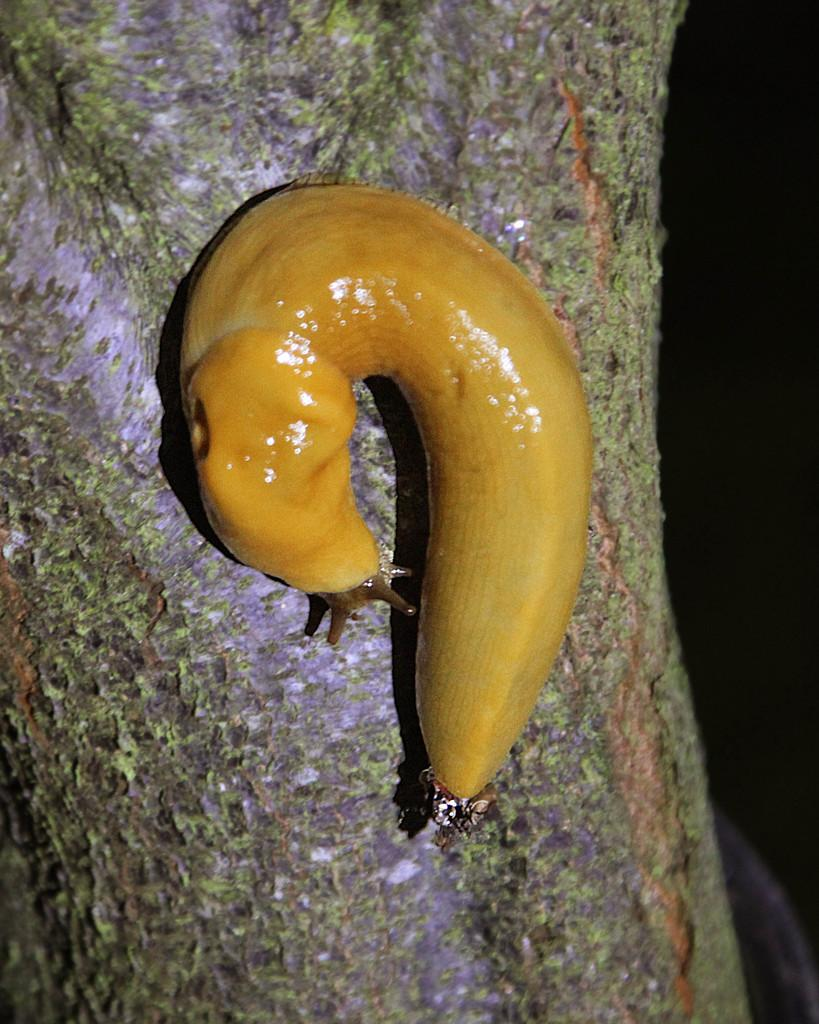What type of animal is in the image? There is a snail in the image. What color is the snail? The snail is brown in color. Where is the snail located? The snail is on a tree. What type of quilt is being used to cover the geese in the image? There are no geese or quilts present in the image; it features a brown snail on a tree. 